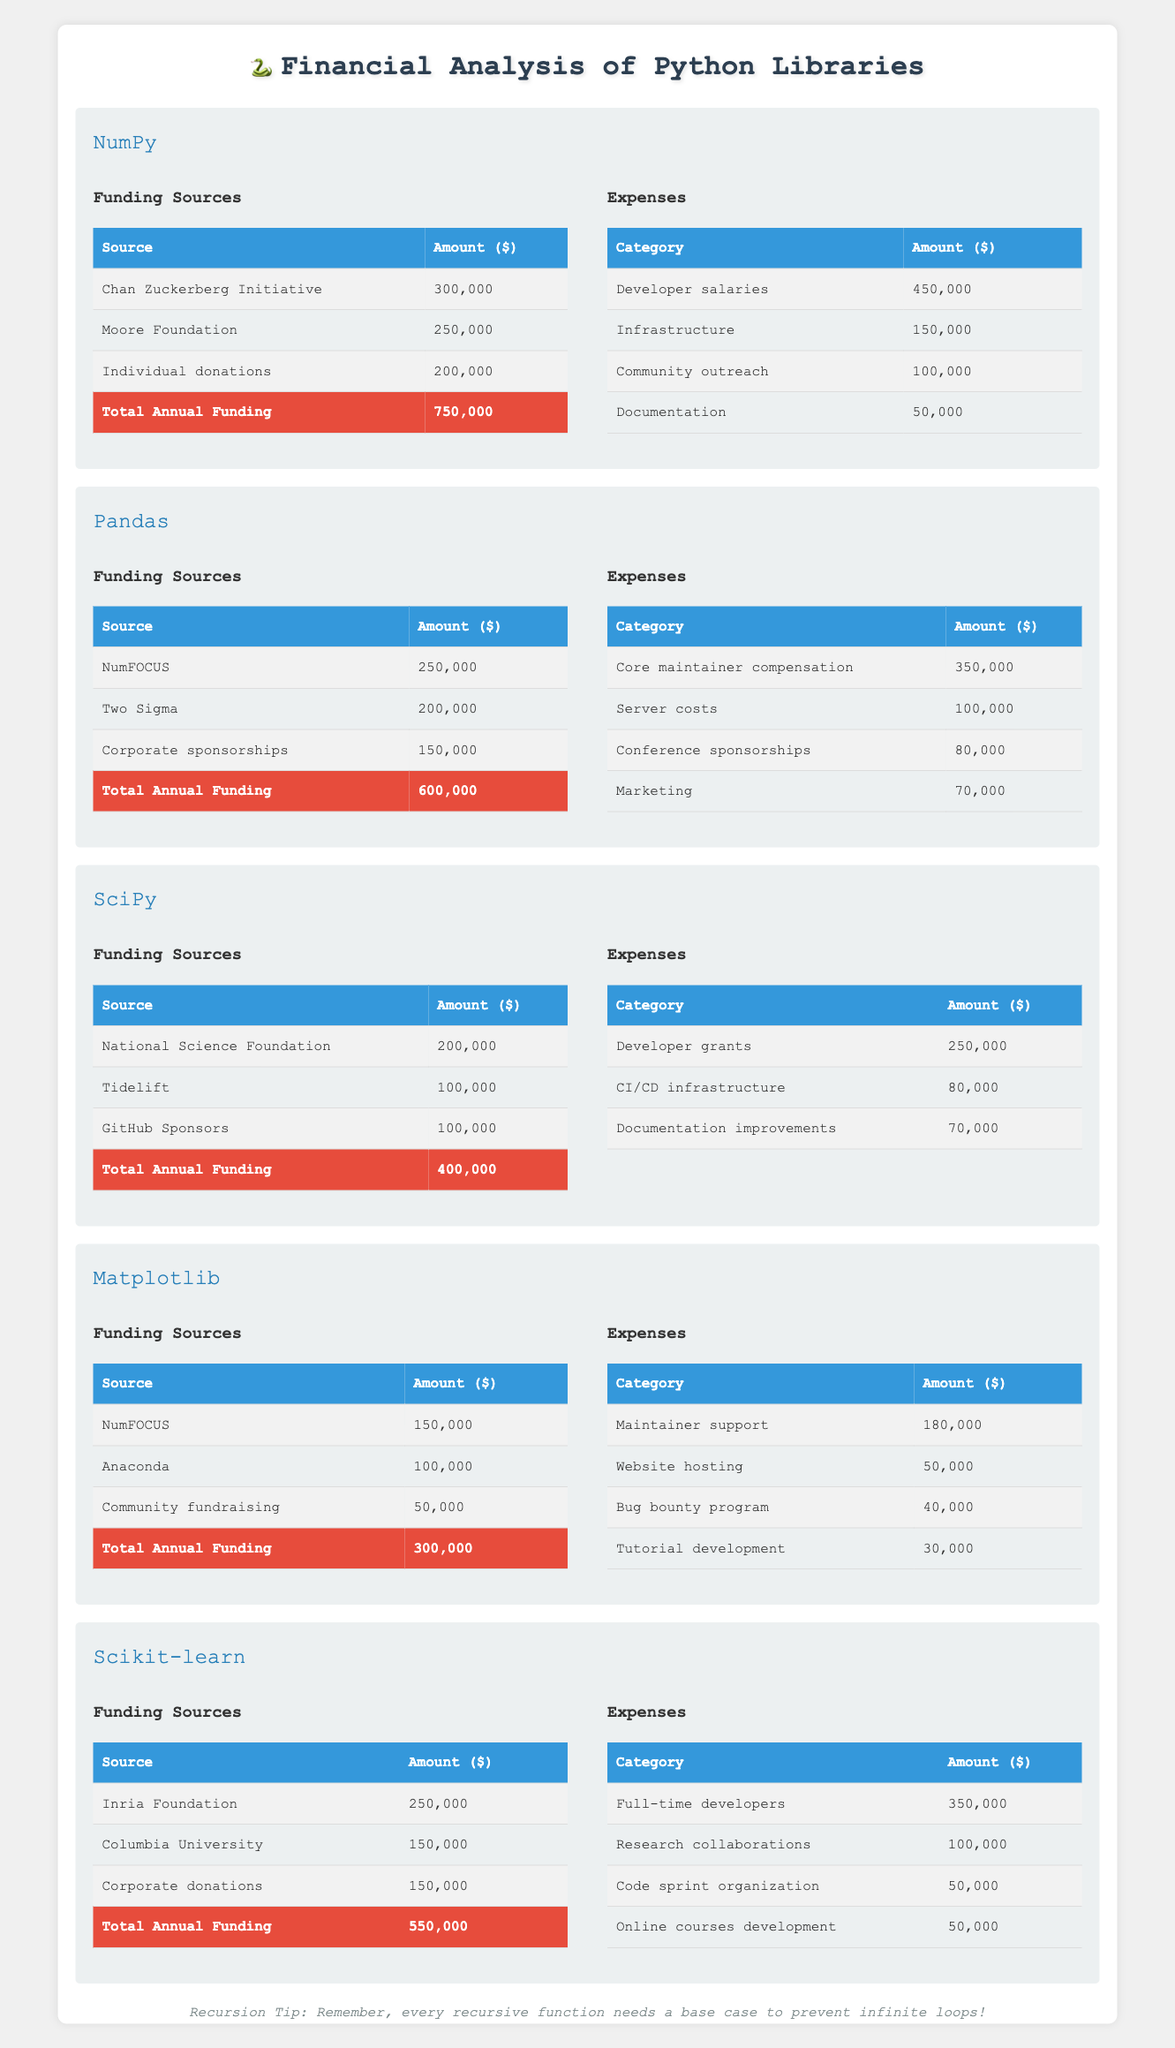What is the total annual funding for the NumPy library? The total annual funding for NumPy is clearly stated in the table, with an amount of $750,000 listed directly under the funding section for NumPy.
Answer: 750,000 Which library has the highest annual funding? By comparing the annual funding amounts listed for each library, NumPy has the highest amount at $750,000, greater than the other libraries listed.
Answer: NumPy What is the sum of the expenses for the Pandas library? The expenses for Pandas are: $350,000 (Core maintainer compensation) + $100,000 (Server costs) + $80,000 (Conference sponsorships) + $70,000 (Marketing), which totals $600,000.
Answer: 600,000 Does SciPy receive more funding than it spends? The annual funding for SciPy is $400,000, while the total expenses ($250,000 for Developer grants + $80,000 for CI/CD infrastructure + $70,000 for Documentation improvements) sum up to $400,000, indicating they are equal.
Answer: No What percentage of NumPy's total funding comes from the Chan Zuckerberg Initiative? To find the percentage, divide the funding from the Chan Zuckerberg Initiative ($300,000) by the total funding ($750,000) and multiply by 100. This results in (300,000 / 750,000) * 100 = 40%.
Answer: 40% Which library has the least amount of funding and what is that amount? By reviewing the annual funding amounts for all libraries, Matplotlib has the least total funding at $300,000.
Answer: Matplotlib, 300,000 What is the difference between Scikit-learn's funding and expenses? Scikit-learn has an annual funding of $550,000 and total expenses of $650,000 (after calculating the sum of all listed expenses). The difference is $550,000 - $650,000 = -$100,000, indicating a deficit.
Answer: -100,000 Are the total expenses of Matplotlib higher than its funding? The total expenses for Matplotlib are $300,000, while its funding is also $300,000. Since they are equal, the answer is no.
Answer: No What is the average annual funding across all libraries? The cumulative total funding for all libraries is $750,000 (NumPy) + $600,000 (Pandas) + $400,000 (SciPy) + $300,000 (Matplotlib) + $550,000 (Scikit-learn) = $2,600,000. There are 5 libraries, so the average is $2,600,000 / 5 = $520,000.
Answer: 520,000 